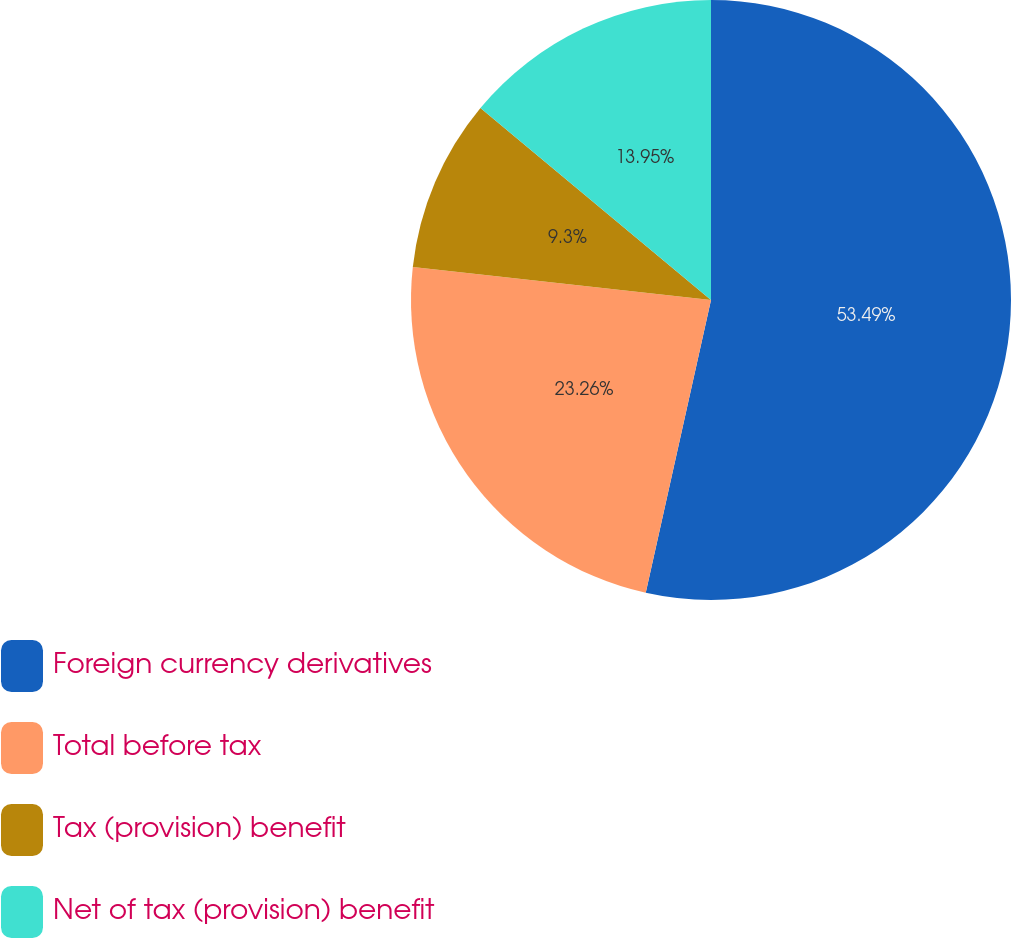<chart> <loc_0><loc_0><loc_500><loc_500><pie_chart><fcel>Foreign currency derivatives<fcel>Total before tax<fcel>Tax (provision) benefit<fcel>Net of tax (provision) benefit<nl><fcel>53.49%<fcel>23.26%<fcel>9.3%<fcel>13.95%<nl></chart> 